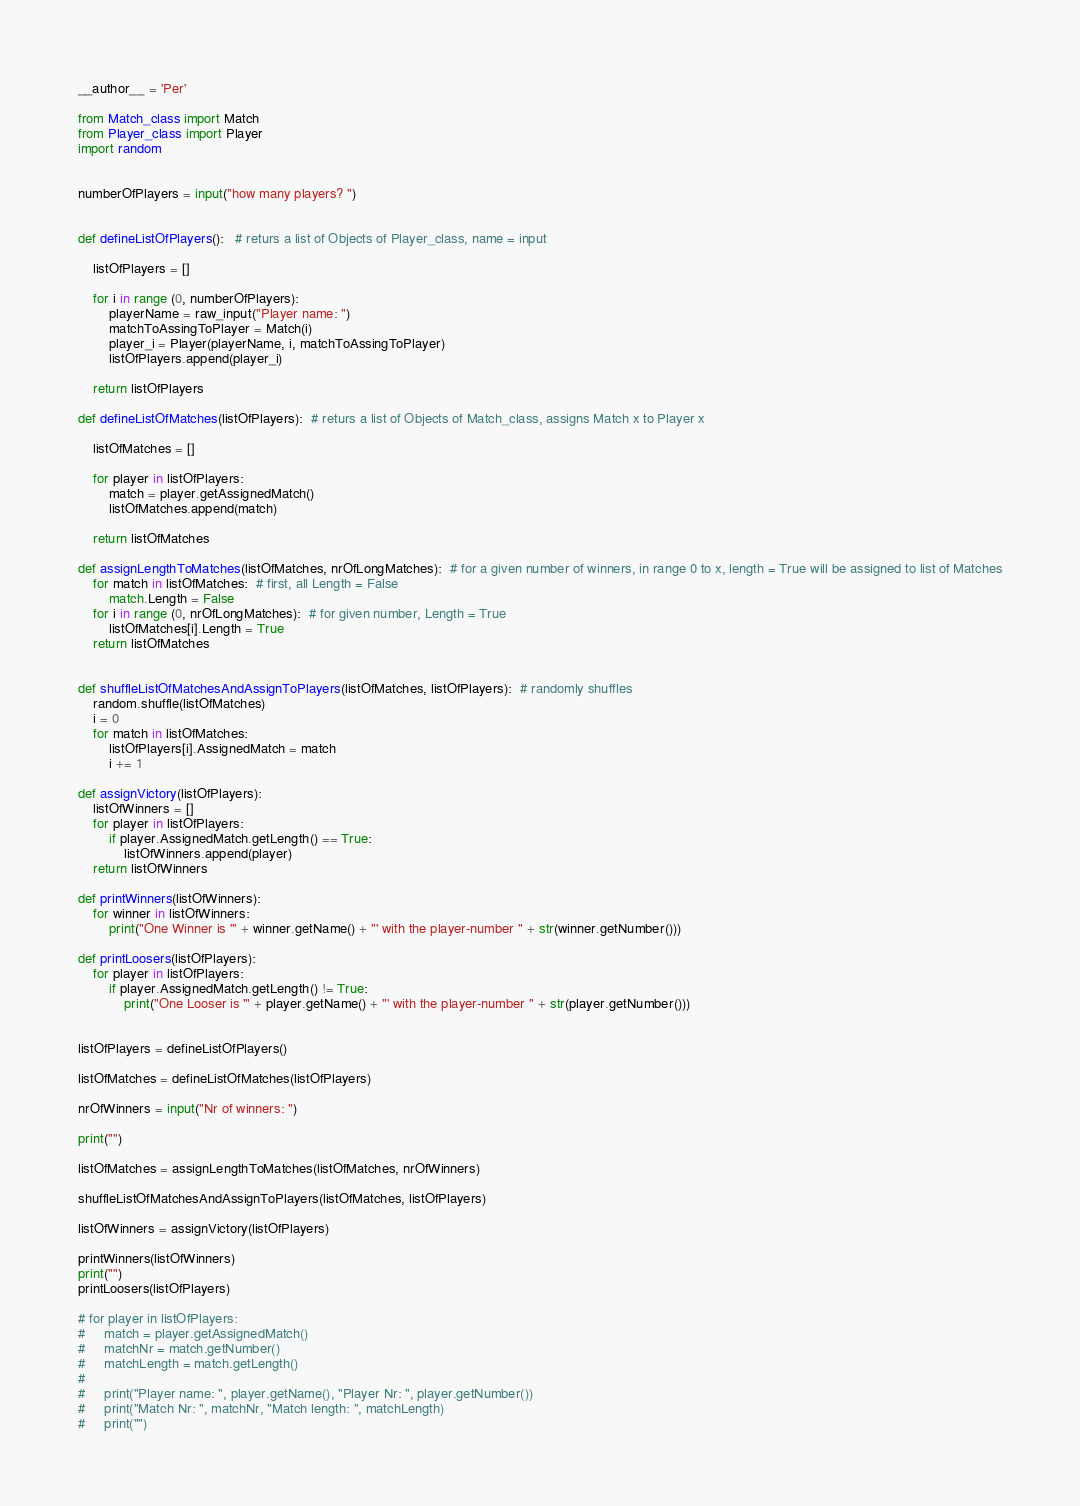<code> <loc_0><loc_0><loc_500><loc_500><_Python_>__author__ = 'Per'

from Match_class import Match
from Player_class import Player
import random


numberOfPlayers = input("how many players? ")


def defineListOfPlayers():   # returs a list of Objects of Player_class, name = input

    listOfPlayers = []

    for i in range (0, numberOfPlayers):
        playerName = raw_input("Player name: ")
        matchToAssingToPlayer = Match(i)
        player_i = Player(playerName, i, matchToAssingToPlayer)
        listOfPlayers.append(player_i)

    return listOfPlayers

def defineListOfMatches(listOfPlayers):  # returs a list of Objects of Match_class, assigns Match x to Player x

    listOfMatches = []

    for player in listOfPlayers:
        match = player.getAssignedMatch()
        listOfMatches.append(match)

    return listOfMatches

def assignLengthToMatches(listOfMatches, nrOfLongMatches):  # for a given number of winners, in range 0 to x, length = True will be assigned to list of Matches
    for match in listOfMatches:  # first, all Length = False
        match.Length = False
    for i in range (0, nrOfLongMatches):  # for given number, Length = True
        listOfMatches[i].Length = True
    return listOfMatches


def shuffleListOfMatchesAndAssignToPlayers(listOfMatches, listOfPlayers):  # randomly shuffles 
    random.shuffle(listOfMatches)
    i = 0
    for match in listOfMatches:
        listOfPlayers[i].AssignedMatch = match
        i += 1

def assignVictory(listOfPlayers):
    listOfWinners = []
    for player in listOfPlayers:
        if player.AssignedMatch.getLength() == True:
            listOfWinners.append(player)
    return listOfWinners

def printWinners(listOfWinners):
    for winner in listOfWinners:
        print("One Winner is '" + winner.getName() + "' with the player-number " + str(winner.getNumber()))

def printLoosers(listOfPlayers):
    for player in listOfPlayers:
        if player.AssignedMatch.getLength() != True:
            print("One Looser is '" + player.getName() + "' with the player-number " + str(player.getNumber()))


listOfPlayers = defineListOfPlayers()

listOfMatches = defineListOfMatches(listOfPlayers)

nrOfWinners = input("Nr of winners: ")

print("")

listOfMatches = assignLengthToMatches(listOfMatches, nrOfWinners)

shuffleListOfMatchesAndAssignToPlayers(listOfMatches, listOfPlayers)

listOfWinners = assignVictory(listOfPlayers)

printWinners(listOfWinners)
print("")
printLoosers(listOfPlayers)

# for player in listOfPlayers:
#     match = player.getAssignedMatch()
#     matchNr = match.getNumber()
#     matchLength = match.getLength()
#
#     print("Player name: ", player.getName(), "Player Nr: ", player.getNumber())
#     print("Match Nr: ", matchNr, "Match length: ", matchLength)
#     print("")</code> 